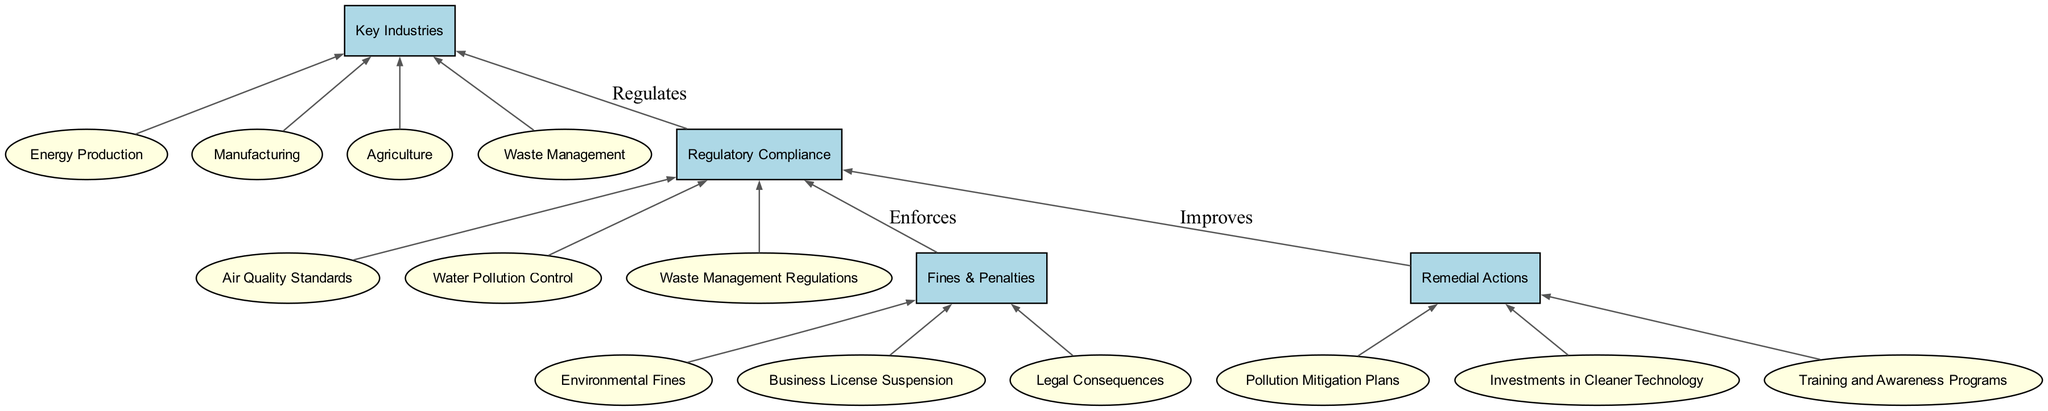What are the key industries covered in this diagram? The diagram lists four key industries: Energy Production, Manufacturing, Agriculture, and Waste Management, which are subject to environmental regulations.
Answer: Energy Production, Manufacturing, Agriculture, Waste Management How many regulatory compliance standards are mentioned? The diagram outlines three compliance standards: Air Quality Standards, Water Pollution Control, and Waste Management Regulations. This is derived from counting the sub-elements under the Regulatory Compliance section.
Answer: 3 What is the relationship between Regulatory Compliance and Key Industries? Regulatory Compliance regulates the Key Industries as indicated by the edge labeled 'Regulates' that connects the two elements.
Answer: Regulates Which fines and penalties are detailed in the diagram? The diagram enumerates three fines and penalties: Environmental Fines, Business License Suspension, and Legal Consequences. These are described as sub-elements under the Fines & Penalties category.
Answer: Environmental Fines, Business License Suspension, Legal Consequences What type of remedial action is focused on technological investments? The remedial action aimed at technological advancements is titled "Investments in Cleaner Technology," indicating a focus on sustainable production methods.
Answer: Investments in Cleaner Technology How do remedial actions relate to regulatory compliance? The diagram shows that Remedial Actions are intended to improve compliance with the regulatory standards, as evidenced by the directed edge labeled 'Improves' connecting these elements.
Answer: Improves What element is directly connected to Air Quality Standards? Air Quality Standards is connected directly to Regulatory Compliance, indicating that it is one of the standards to which industries must adhere.
Answer: Regulatory Compliance Which key industry is concerned with hazardous waste? The key industry involved with hazardous waste is Waste Management, as it includes operations related to recycling and hazardous waste disposal.
Answer: Waste Management What consequences can result from non-compliance according to the diagram? The diagram highlights several legal consequences related to non-compliance, including Environmental Fines, Business License Suspension, and potential litigation.
Answer: Environmental Fines, Business License Suspension, Legal Consequences 